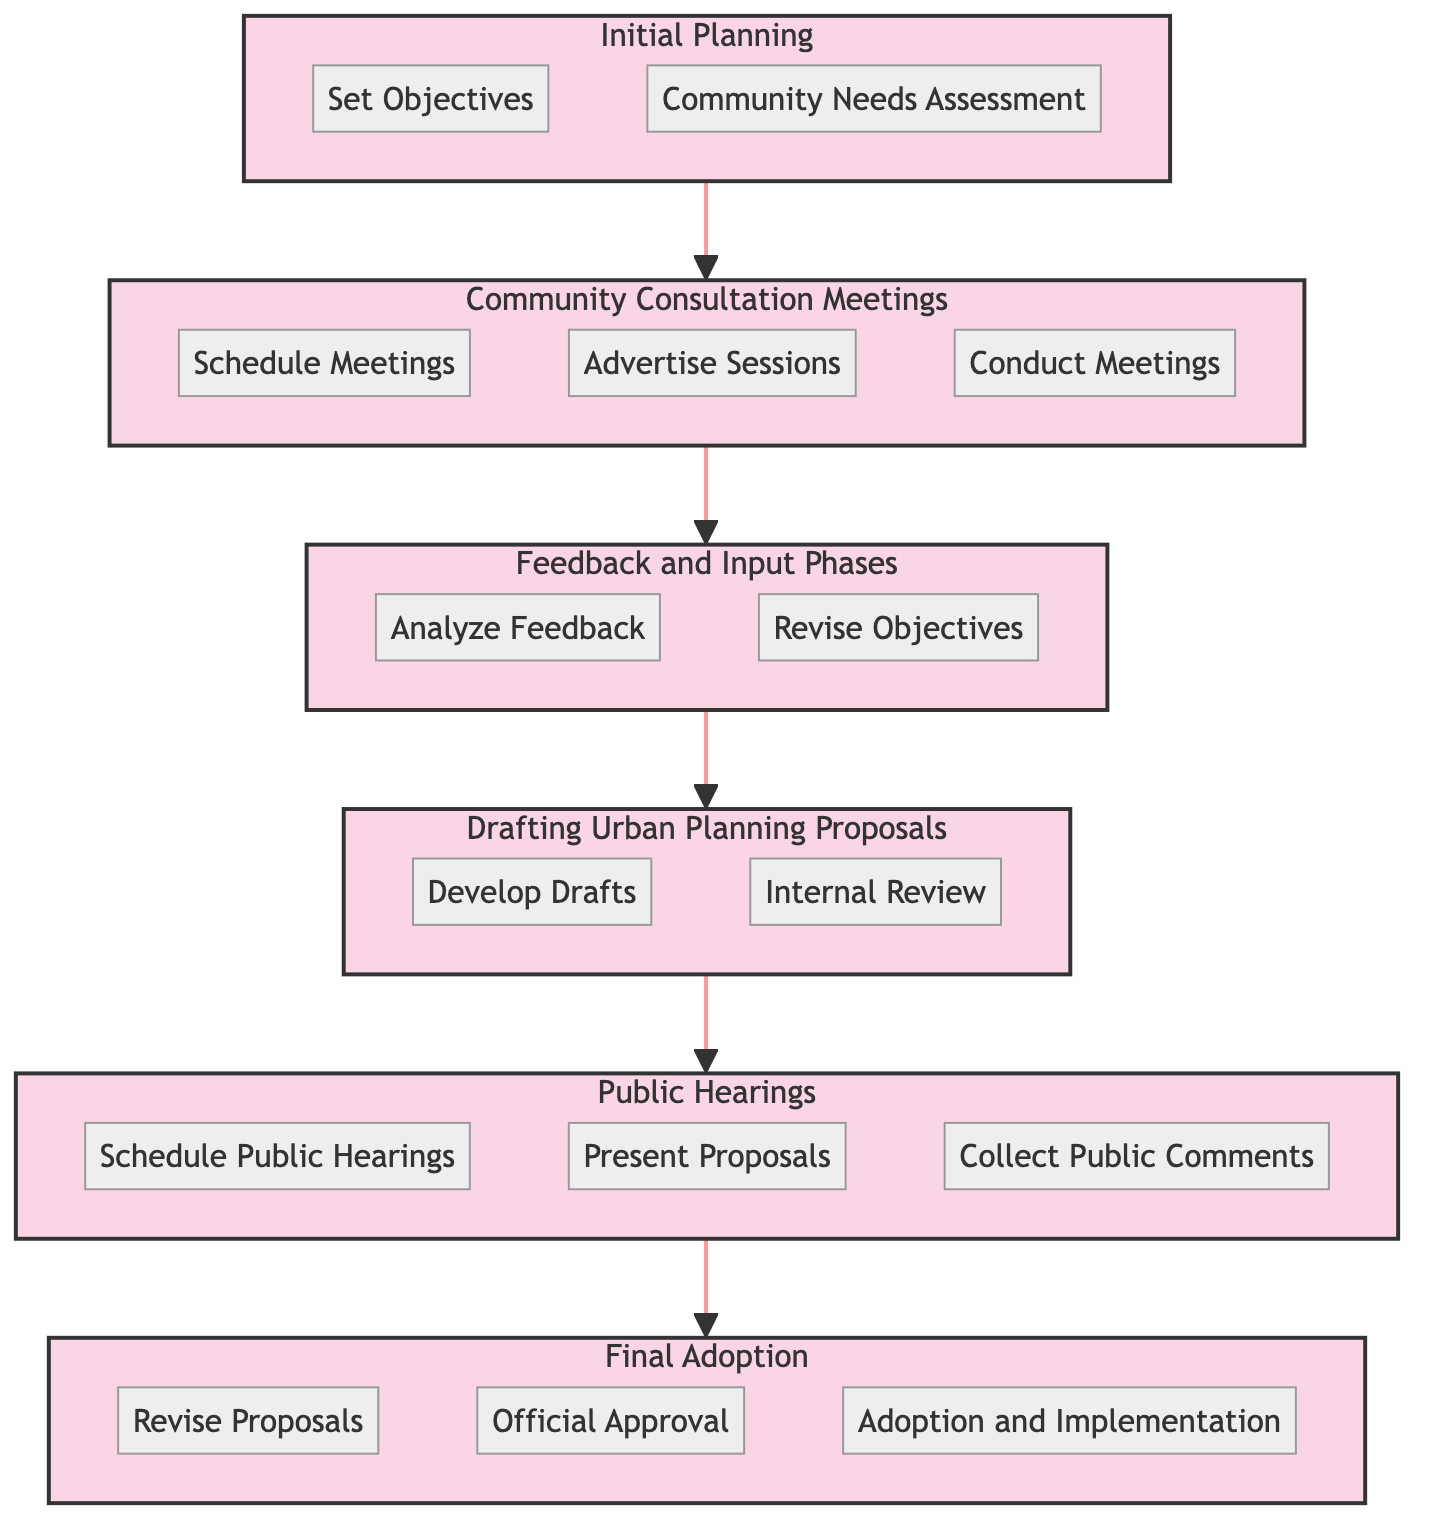What is the first stage in the diagram? The diagram begins with the "Initial Planning" stage, as indicated by the first block in the flowchart.
Answer: Initial Planning How many actions are there in the "Community Consultation Meetings" stage? There are three actions listed under the "Community Consultation Meetings" stage: "Schedule Meetings," "Advertise Sessions," and "Conduct Meetings." Counting these gives a total of three actions.
Answer: 3 What stage comes after "Feedback and Input Phases"? The diagram shows that after "Feedback and Input Phases," the next stage is "Drafting Urban Planning Proposals," indicated by the directional flow connecting the two stages.
Answer: Drafting Urban Planning Proposals Which action involves collecting feedback from the public? The action that involves this is "Collect Public Comments," located in the "Public Hearings" stage, as it specifically relates to gathering feedback during public engagement.
Answer: Collect Public Comments What is the last action taken before final adoption of the plans? The last action before the final adoption is "Revise Proposals," which is crucial for making adjustments based on the feedback received in the public hearings stage.
Answer: Revise Proposals How many total stages are present in this flowchart? The flowchart contains six distinct stages: Initial Planning, Community Consultation Meetings, Feedback and Input Phases, Drafting Urban Planning Proposals, Public Hearings, and Final Adoption. Counting these gives a total of six stages.
Answer: 6 What action immediately follows "Develop Drafts"? The action that follows "Develop Drafts" is "Internal Review," indicating that after drafts are developed, they undergo internal scrutiny.
Answer: Internal Review Which stage includes actions related to community engagement? The "Community Consultation Meetings" stage includes actions focused on community engagement, such as "Schedule Meetings," "Advertise Sessions," and "Conduct Meetings."
Answer: Community Consultation Meetings What is the ultimate goal of the urban planning process as indicated in the last stage? The ultimate goal as indicated in the last stage "Final Adoption" is "Adoption and Implementation," which signifies the beginning of the plan's execution after approval.
Answer: Adoption and Implementation 